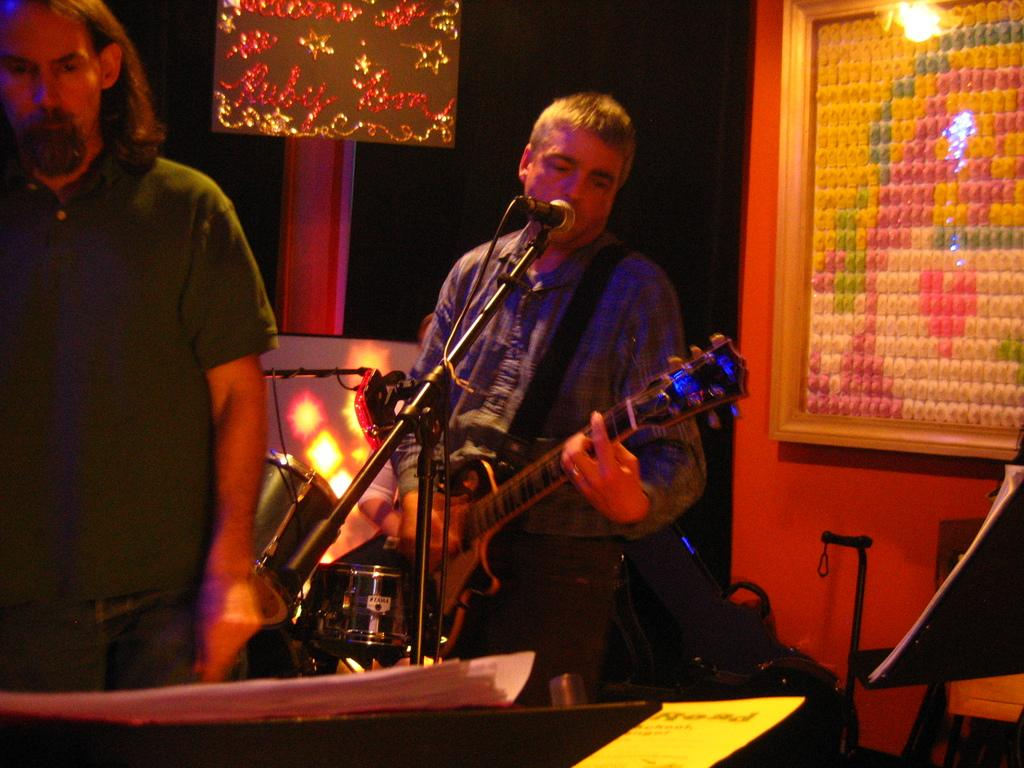What is the person in the image holding? The person in the image is holding a musical instrument. What can be seen on the wall in the image? There is a photo frame on the wall in the image. What is on the decorative board in the image? There is a decorative board with text in the image. Can you describe the other person in the image? There is a man standing in the image. What type of corn is being served on the sink in the image? There is no sink or corn present in the image. What day of the week is depicted in the image? The provided facts do not mention any specific day of the week, and the image does not show any indication of a particular day. 